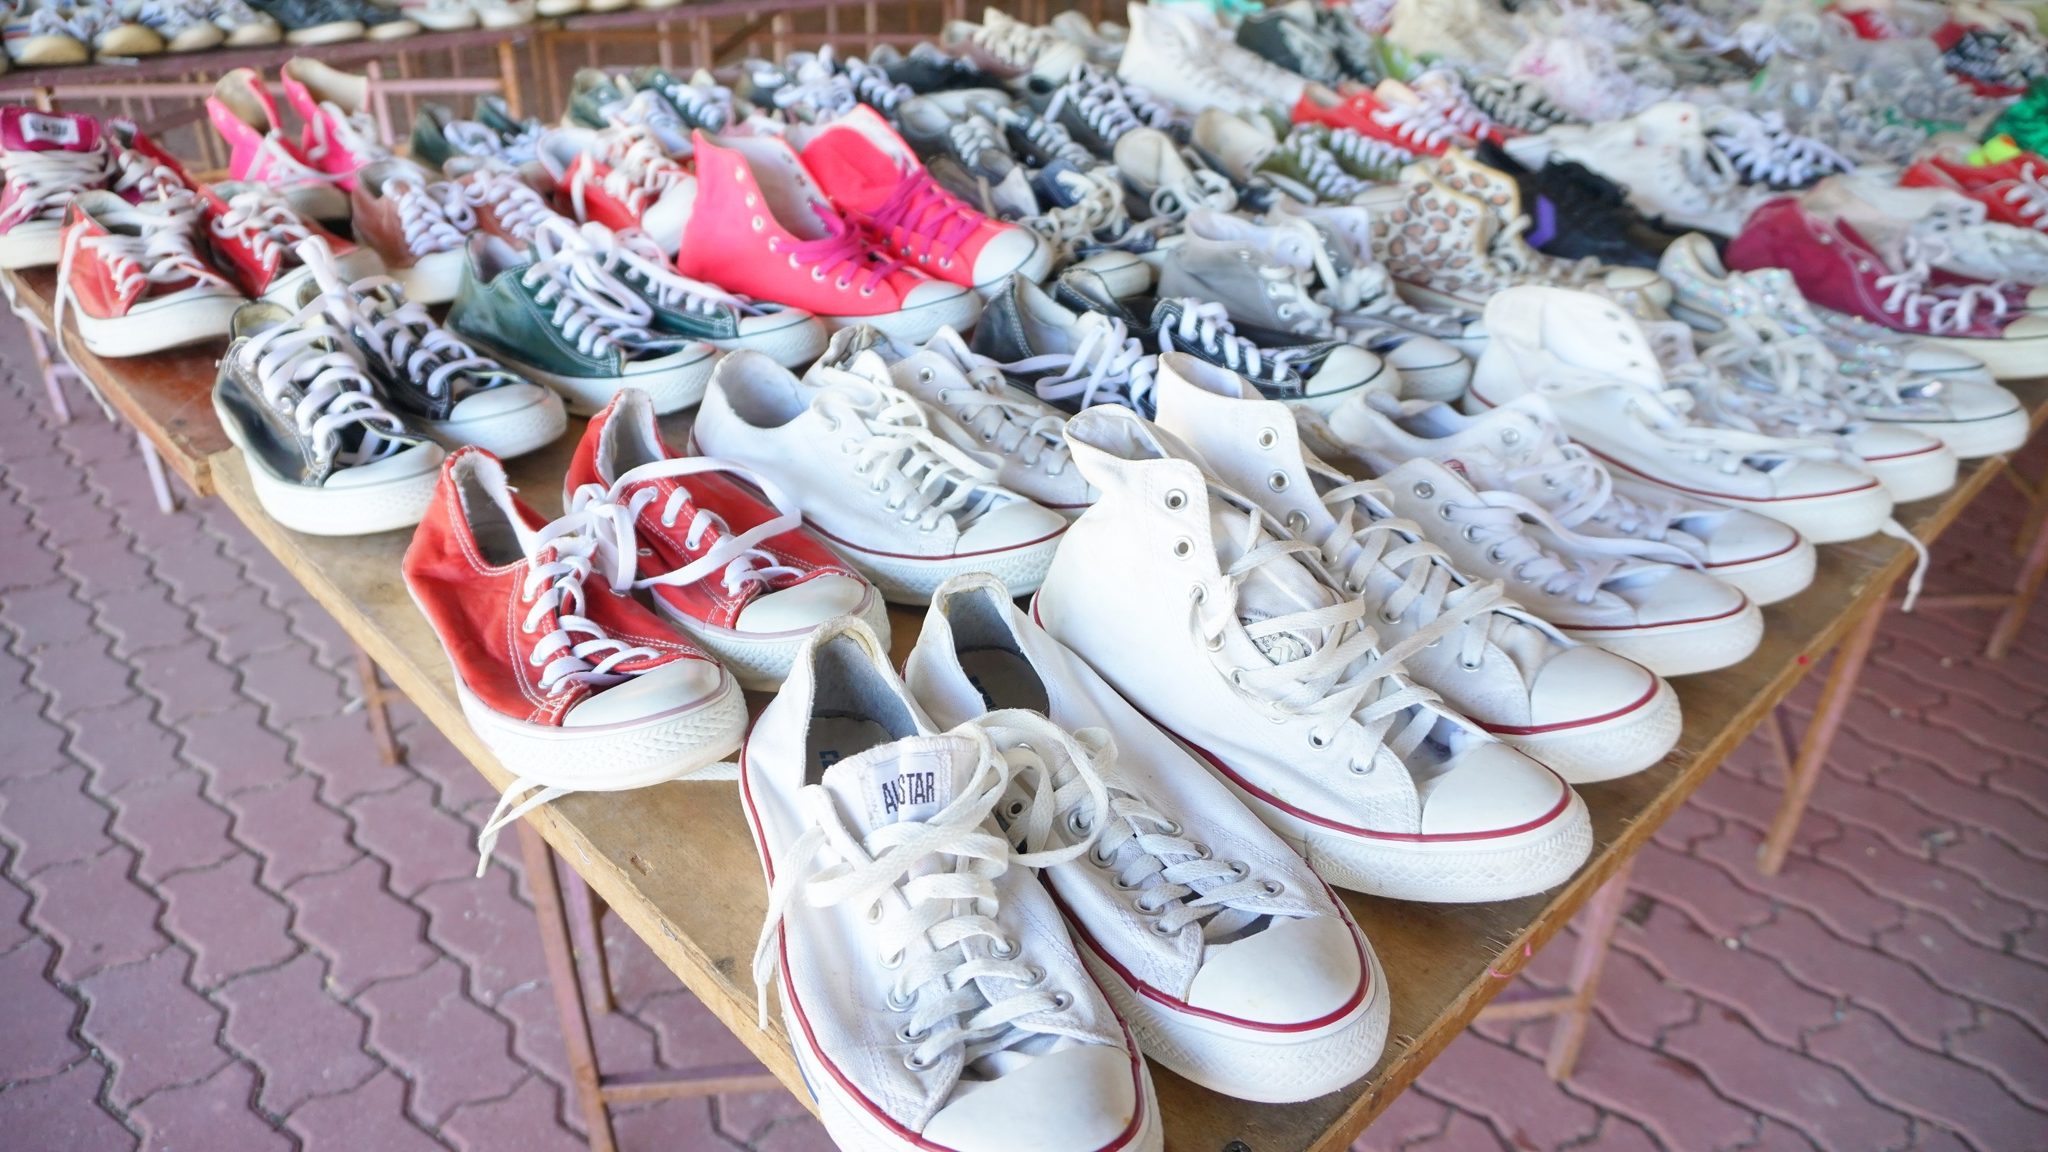What could be the story behind these sneakers? Each of these sneakers could have a unique story. Perhaps they were cherished by their previous owners during memorable life events like high school sports games, concerts, or travel adventures. They might have been traded among friends or rediscovered in the back of a closet after years. Selling them at this market could be a way for the previous owners to pass on a piece of their history while making room for new adventures. Imagine if these sneakers could talk, what stories would they tell? If these sneakers could talk, they might share tales of late-night adventures, concerts where the music was so loud it reverberated through their soles, and spontaneous road trips to the beach. They could recount the exhilarating moments of being worn during a winning basketball game or the mundane, like trudging through rain to a classroom. Some might tell stories of festivals where they were painted in vibrant colors, while others might whisper secrets of first dates and long city walks. What are the practical considerations when buying used sneakers from a sale like this? When buying used sneakers, practical considerations include checking the overall condition of the shoes for wear and tear, ensuring the size fits correctly, and verifying that the soles and laces are intact. A good clean and disinfecting session might be necessary. Considering the price relative to the brand and condition also helps ensure you get value for your money. Lastly, look out for any modifications or damages that may affect comfort or durability. What type of buyer is likely to be most interested in this sale? The most likely buyers are sneaker enthusiasts looking for rare or vintage styles, budget-conscious shoppers wanting to score a good deal, or fashion-forward individuals seeking unique and worn-in sneakers to complement their personal style. Additionally, environmentally-conscious buyers might be drawn to purchasing second-hand items as a way to reduce waste and promote sustainability. 